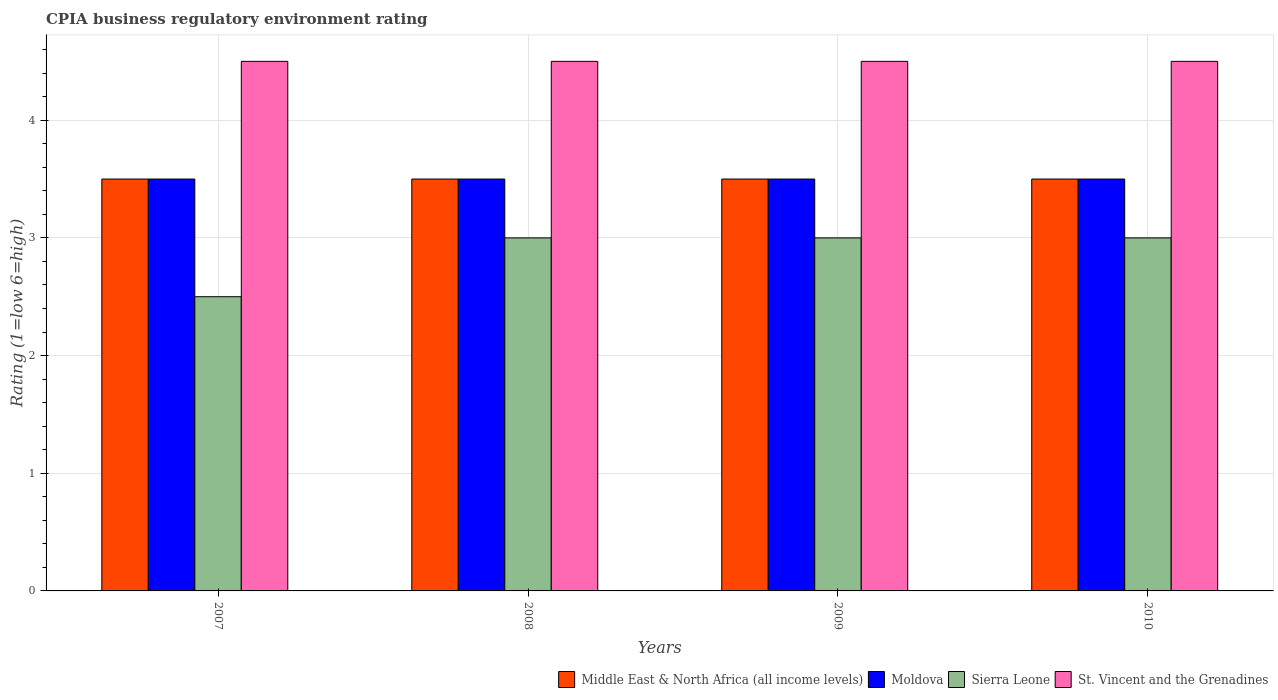Are the number of bars per tick equal to the number of legend labels?
Your answer should be very brief. Yes. How many bars are there on the 4th tick from the right?
Keep it short and to the point. 4. What is the label of the 3rd group of bars from the left?
Your response must be concise. 2009. What is the CPIA rating in Middle East & North Africa (all income levels) in 2008?
Make the answer very short. 3.5. In which year was the CPIA rating in Moldova maximum?
Provide a short and direct response. 2007. In which year was the CPIA rating in St. Vincent and the Grenadines minimum?
Your answer should be compact. 2007. What is the difference between the CPIA rating in Moldova in 2008 and the CPIA rating in St. Vincent and the Grenadines in 2009?
Offer a very short reply. -1. What is the average CPIA rating in Sierra Leone per year?
Your response must be concise. 2.88. What is the difference between the highest and the lowest CPIA rating in St. Vincent and the Grenadines?
Provide a short and direct response. 0. Is the sum of the CPIA rating in Sierra Leone in 2007 and 2009 greater than the maximum CPIA rating in St. Vincent and the Grenadines across all years?
Offer a terse response. Yes. What does the 4th bar from the left in 2007 represents?
Give a very brief answer. St. Vincent and the Grenadines. What does the 2nd bar from the right in 2007 represents?
Keep it short and to the point. Sierra Leone. Is it the case that in every year, the sum of the CPIA rating in Sierra Leone and CPIA rating in Middle East & North Africa (all income levels) is greater than the CPIA rating in St. Vincent and the Grenadines?
Your response must be concise. Yes. How many bars are there?
Provide a succinct answer. 16. Are all the bars in the graph horizontal?
Give a very brief answer. No. How many years are there in the graph?
Provide a succinct answer. 4. Does the graph contain grids?
Your response must be concise. Yes. Where does the legend appear in the graph?
Offer a very short reply. Bottom right. How many legend labels are there?
Offer a very short reply. 4. How are the legend labels stacked?
Your answer should be very brief. Horizontal. What is the title of the graph?
Your answer should be very brief. CPIA business regulatory environment rating. What is the label or title of the X-axis?
Make the answer very short. Years. What is the label or title of the Y-axis?
Offer a very short reply. Rating (1=low 6=high). What is the Rating (1=low 6=high) in St. Vincent and the Grenadines in 2007?
Keep it short and to the point. 4.5. What is the Rating (1=low 6=high) in Middle East & North Africa (all income levels) in 2008?
Ensure brevity in your answer.  3.5. What is the Rating (1=low 6=high) in Moldova in 2008?
Provide a short and direct response. 3.5. What is the Rating (1=low 6=high) of Sierra Leone in 2008?
Offer a very short reply. 3. What is the Rating (1=low 6=high) in Moldova in 2009?
Your answer should be very brief. 3.5. What is the Rating (1=low 6=high) of St. Vincent and the Grenadines in 2009?
Give a very brief answer. 4.5. What is the Rating (1=low 6=high) of Moldova in 2010?
Make the answer very short. 3.5. What is the Rating (1=low 6=high) of Sierra Leone in 2010?
Ensure brevity in your answer.  3. Across all years, what is the maximum Rating (1=low 6=high) of Sierra Leone?
Give a very brief answer. 3. Across all years, what is the maximum Rating (1=low 6=high) of St. Vincent and the Grenadines?
Keep it short and to the point. 4.5. Across all years, what is the minimum Rating (1=low 6=high) of Sierra Leone?
Offer a terse response. 2.5. What is the total Rating (1=low 6=high) in St. Vincent and the Grenadines in the graph?
Provide a short and direct response. 18. What is the difference between the Rating (1=low 6=high) of Moldova in 2007 and that in 2008?
Offer a terse response. 0. What is the difference between the Rating (1=low 6=high) of Sierra Leone in 2007 and that in 2008?
Provide a short and direct response. -0.5. What is the difference between the Rating (1=low 6=high) in St. Vincent and the Grenadines in 2007 and that in 2008?
Ensure brevity in your answer.  0. What is the difference between the Rating (1=low 6=high) in Middle East & North Africa (all income levels) in 2007 and that in 2009?
Your answer should be very brief. 0. What is the difference between the Rating (1=low 6=high) in St. Vincent and the Grenadines in 2007 and that in 2009?
Your answer should be very brief. 0. What is the difference between the Rating (1=low 6=high) in Middle East & North Africa (all income levels) in 2007 and that in 2010?
Provide a short and direct response. 0. What is the difference between the Rating (1=low 6=high) of Sierra Leone in 2007 and that in 2010?
Ensure brevity in your answer.  -0.5. What is the difference between the Rating (1=low 6=high) of Middle East & North Africa (all income levels) in 2008 and that in 2009?
Provide a short and direct response. 0. What is the difference between the Rating (1=low 6=high) in Moldova in 2008 and that in 2009?
Your answer should be very brief. 0. What is the difference between the Rating (1=low 6=high) of Sierra Leone in 2008 and that in 2009?
Provide a short and direct response. 0. What is the difference between the Rating (1=low 6=high) in Middle East & North Africa (all income levels) in 2008 and that in 2010?
Offer a terse response. 0. What is the difference between the Rating (1=low 6=high) of Moldova in 2008 and that in 2010?
Keep it short and to the point. 0. What is the difference between the Rating (1=low 6=high) in Sierra Leone in 2008 and that in 2010?
Your response must be concise. 0. What is the difference between the Rating (1=low 6=high) of St. Vincent and the Grenadines in 2008 and that in 2010?
Your answer should be very brief. 0. What is the difference between the Rating (1=low 6=high) in Middle East & North Africa (all income levels) in 2009 and that in 2010?
Offer a very short reply. 0. What is the difference between the Rating (1=low 6=high) in St. Vincent and the Grenadines in 2009 and that in 2010?
Your answer should be compact. 0. What is the difference between the Rating (1=low 6=high) of Middle East & North Africa (all income levels) in 2007 and the Rating (1=low 6=high) of Moldova in 2008?
Keep it short and to the point. 0. What is the difference between the Rating (1=low 6=high) in Moldova in 2007 and the Rating (1=low 6=high) in Sierra Leone in 2008?
Provide a succinct answer. 0.5. What is the difference between the Rating (1=low 6=high) in Moldova in 2007 and the Rating (1=low 6=high) in St. Vincent and the Grenadines in 2008?
Ensure brevity in your answer.  -1. What is the difference between the Rating (1=low 6=high) of Moldova in 2007 and the Rating (1=low 6=high) of St. Vincent and the Grenadines in 2009?
Provide a succinct answer. -1. What is the difference between the Rating (1=low 6=high) in Middle East & North Africa (all income levels) in 2007 and the Rating (1=low 6=high) in Sierra Leone in 2010?
Provide a succinct answer. 0.5. What is the difference between the Rating (1=low 6=high) in Middle East & North Africa (all income levels) in 2007 and the Rating (1=low 6=high) in St. Vincent and the Grenadines in 2010?
Offer a very short reply. -1. What is the difference between the Rating (1=low 6=high) in Moldova in 2007 and the Rating (1=low 6=high) in Sierra Leone in 2010?
Keep it short and to the point. 0.5. What is the difference between the Rating (1=low 6=high) in Sierra Leone in 2008 and the Rating (1=low 6=high) in St. Vincent and the Grenadines in 2009?
Offer a very short reply. -1.5. What is the difference between the Rating (1=low 6=high) in Middle East & North Africa (all income levels) in 2008 and the Rating (1=low 6=high) in Moldova in 2010?
Ensure brevity in your answer.  0. What is the difference between the Rating (1=low 6=high) of Middle East & North Africa (all income levels) in 2008 and the Rating (1=low 6=high) of St. Vincent and the Grenadines in 2010?
Keep it short and to the point. -1. What is the difference between the Rating (1=low 6=high) of Moldova in 2008 and the Rating (1=low 6=high) of St. Vincent and the Grenadines in 2010?
Provide a succinct answer. -1. What is the difference between the Rating (1=low 6=high) of Sierra Leone in 2008 and the Rating (1=low 6=high) of St. Vincent and the Grenadines in 2010?
Your answer should be compact. -1.5. What is the difference between the Rating (1=low 6=high) of Middle East & North Africa (all income levels) in 2009 and the Rating (1=low 6=high) of Moldova in 2010?
Keep it short and to the point. 0. What is the difference between the Rating (1=low 6=high) of Moldova in 2009 and the Rating (1=low 6=high) of Sierra Leone in 2010?
Ensure brevity in your answer.  0.5. What is the difference between the Rating (1=low 6=high) of Moldova in 2009 and the Rating (1=low 6=high) of St. Vincent and the Grenadines in 2010?
Ensure brevity in your answer.  -1. What is the difference between the Rating (1=low 6=high) of Sierra Leone in 2009 and the Rating (1=low 6=high) of St. Vincent and the Grenadines in 2010?
Your answer should be compact. -1.5. What is the average Rating (1=low 6=high) of Sierra Leone per year?
Give a very brief answer. 2.88. In the year 2007, what is the difference between the Rating (1=low 6=high) in Middle East & North Africa (all income levels) and Rating (1=low 6=high) in Moldova?
Ensure brevity in your answer.  0. In the year 2007, what is the difference between the Rating (1=low 6=high) in Middle East & North Africa (all income levels) and Rating (1=low 6=high) in Sierra Leone?
Offer a terse response. 1. In the year 2007, what is the difference between the Rating (1=low 6=high) in Middle East & North Africa (all income levels) and Rating (1=low 6=high) in St. Vincent and the Grenadines?
Keep it short and to the point. -1. In the year 2008, what is the difference between the Rating (1=low 6=high) in Middle East & North Africa (all income levels) and Rating (1=low 6=high) in Moldova?
Make the answer very short. 0. In the year 2008, what is the difference between the Rating (1=low 6=high) of Middle East & North Africa (all income levels) and Rating (1=low 6=high) of Sierra Leone?
Keep it short and to the point. 0.5. In the year 2008, what is the difference between the Rating (1=low 6=high) of Middle East & North Africa (all income levels) and Rating (1=low 6=high) of St. Vincent and the Grenadines?
Make the answer very short. -1. In the year 2008, what is the difference between the Rating (1=low 6=high) in Moldova and Rating (1=low 6=high) in Sierra Leone?
Your answer should be very brief. 0.5. In the year 2008, what is the difference between the Rating (1=low 6=high) of Moldova and Rating (1=low 6=high) of St. Vincent and the Grenadines?
Make the answer very short. -1. In the year 2009, what is the difference between the Rating (1=low 6=high) in Middle East & North Africa (all income levels) and Rating (1=low 6=high) in Moldova?
Offer a very short reply. 0. In the year 2009, what is the difference between the Rating (1=low 6=high) in Middle East & North Africa (all income levels) and Rating (1=low 6=high) in Sierra Leone?
Keep it short and to the point. 0.5. In the year 2009, what is the difference between the Rating (1=low 6=high) in Sierra Leone and Rating (1=low 6=high) in St. Vincent and the Grenadines?
Offer a terse response. -1.5. In the year 2010, what is the difference between the Rating (1=low 6=high) of Middle East & North Africa (all income levels) and Rating (1=low 6=high) of Moldova?
Make the answer very short. 0. In the year 2010, what is the difference between the Rating (1=low 6=high) in Middle East & North Africa (all income levels) and Rating (1=low 6=high) in Sierra Leone?
Your response must be concise. 0.5. In the year 2010, what is the difference between the Rating (1=low 6=high) of Moldova and Rating (1=low 6=high) of Sierra Leone?
Make the answer very short. 0.5. In the year 2010, what is the difference between the Rating (1=low 6=high) in Moldova and Rating (1=low 6=high) in St. Vincent and the Grenadines?
Provide a succinct answer. -1. In the year 2010, what is the difference between the Rating (1=low 6=high) in Sierra Leone and Rating (1=low 6=high) in St. Vincent and the Grenadines?
Give a very brief answer. -1.5. What is the ratio of the Rating (1=low 6=high) of Sierra Leone in 2007 to that in 2008?
Your answer should be compact. 0.83. What is the ratio of the Rating (1=low 6=high) of St. Vincent and the Grenadines in 2007 to that in 2008?
Your answer should be compact. 1. What is the ratio of the Rating (1=low 6=high) in Middle East & North Africa (all income levels) in 2007 to that in 2009?
Your response must be concise. 1. What is the ratio of the Rating (1=low 6=high) of Moldova in 2007 to that in 2009?
Offer a terse response. 1. What is the ratio of the Rating (1=low 6=high) of Sierra Leone in 2007 to that in 2009?
Your answer should be very brief. 0.83. What is the ratio of the Rating (1=low 6=high) in St. Vincent and the Grenadines in 2007 to that in 2009?
Provide a short and direct response. 1. What is the ratio of the Rating (1=low 6=high) of Sierra Leone in 2007 to that in 2010?
Provide a succinct answer. 0.83. What is the ratio of the Rating (1=low 6=high) of Sierra Leone in 2008 to that in 2009?
Offer a very short reply. 1. What is the ratio of the Rating (1=low 6=high) of St. Vincent and the Grenadines in 2008 to that in 2009?
Make the answer very short. 1. What is the ratio of the Rating (1=low 6=high) of Moldova in 2008 to that in 2010?
Provide a succinct answer. 1. What is the ratio of the Rating (1=low 6=high) of St. Vincent and the Grenadines in 2008 to that in 2010?
Ensure brevity in your answer.  1. What is the ratio of the Rating (1=low 6=high) of Moldova in 2009 to that in 2010?
Keep it short and to the point. 1. What is the ratio of the Rating (1=low 6=high) in Sierra Leone in 2009 to that in 2010?
Provide a succinct answer. 1. What is the ratio of the Rating (1=low 6=high) in St. Vincent and the Grenadines in 2009 to that in 2010?
Provide a succinct answer. 1. What is the difference between the highest and the second highest Rating (1=low 6=high) in Moldova?
Provide a succinct answer. 0. What is the difference between the highest and the second highest Rating (1=low 6=high) of Sierra Leone?
Provide a short and direct response. 0. What is the difference between the highest and the second highest Rating (1=low 6=high) in St. Vincent and the Grenadines?
Make the answer very short. 0. What is the difference between the highest and the lowest Rating (1=low 6=high) in Moldova?
Give a very brief answer. 0. What is the difference between the highest and the lowest Rating (1=low 6=high) in Sierra Leone?
Offer a terse response. 0.5. What is the difference between the highest and the lowest Rating (1=low 6=high) of St. Vincent and the Grenadines?
Keep it short and to the point. 0. 